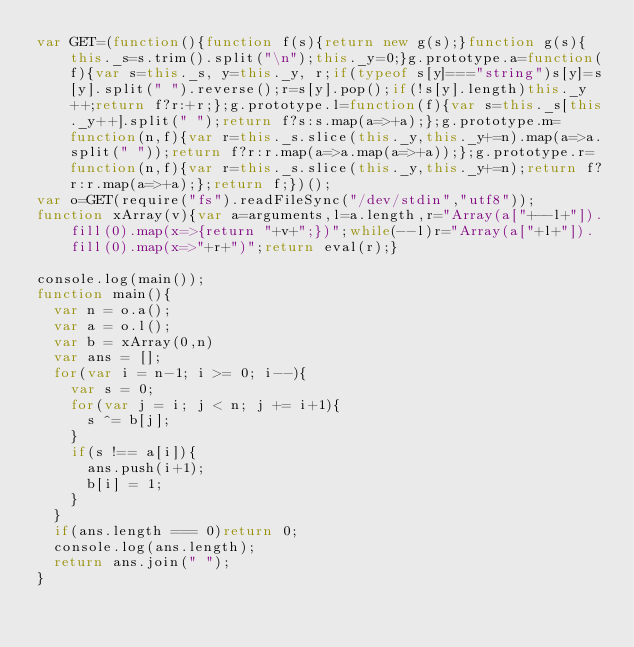Convert code to text. <code><loc_0><loc_0><loc_500><loc_500><_JavaScript_>var GET=(function(){function f(s){return new g(s);}function g(s){this._s=s.trim().split("\n");this._y=0;}g.prototype.a=function(f){var s=this._s, y=this._y, r;if(typeof s[y]==="string")s[y]=s[y].split(" ").reverse();r=s[y].pop();if(!s[y].length)this._y++;return f?r:+r;};g.prototype.l=function(f){var s=this._s[this._y++].split(" ");return f?s:s.map(a=>+a);};g.prototype.m=function(n,f){var r=this._s.slice(this._y,this._y+=n).map(a=>a.split(" "));return f?r:r.map(a=>a.map(a=>+a));};g.prototype.r=function(n,f){var r=this._s.slice(this._y,this._y+=n);return f?r:r.map(a=>+a);};return f;})();
var o=GET(require("fs").readFileSync("/dev/stdin","utf8"));
function xArray(v){var a=arguments,l=a.length,r="Array(a["+--l+"]).fill(0).map(x=>{return "+v+";})";while(--l)r="Array(a["+l+"]).fill(0).map(x=>"+r+")";return eval(r);}

console.log(main());
function main(){
  var n = o.a();
  var a = o.l();
  var b = xArray(0,n)
  var ans = [];
  for(var i = n-1; i >= 0; i--){
    var s = 0;
    for(var j = i; j < n; j += i+1){
      s ^= b[j];
    }
    if(s !== a[i]){
      ans.push(i+1);
      b[i] = 1;
    }
  }
  if(ans.length === 0)return 0;
  console.log(ans.length);
  return ans.join(" ");
}</code> 